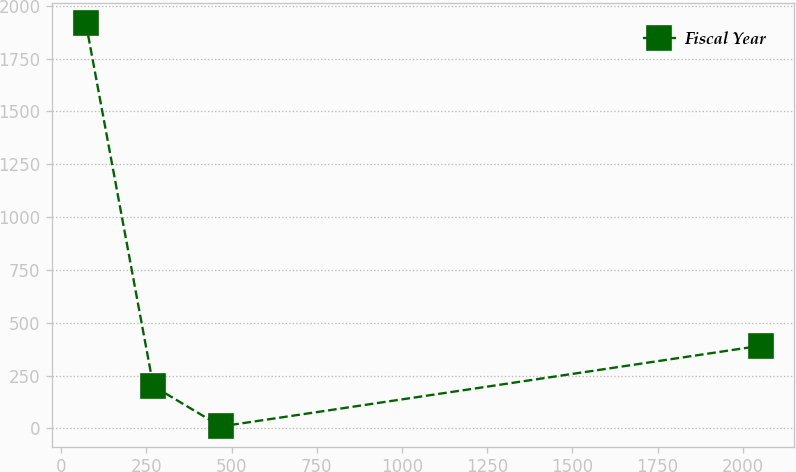Convert chart. <chart><loc_0><loc_0><loc_500><loc_500><line_chart><ecel><fcel>Fiscal Year<nl><fcel>72.26<fcel>1918.55<nl><fcel>270.28<fcel>199.94<nl><fcel>468.3<fcel>8.98<nl><fcel>2052.5<fcel>390.9<nl></chart> 